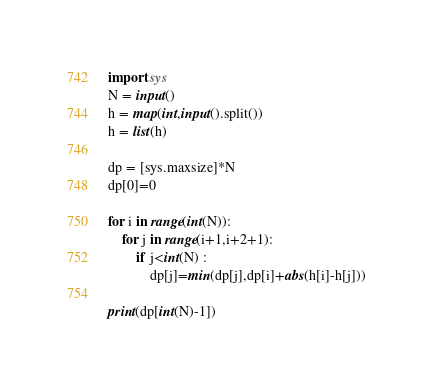<code> <loc_0><loc_0><loc_500><loc_500><_Python_>import sys
N = input()
h = map(int,input().split())
h = list(h)

dp = [sys.maxsize]*N
dp[0]=0

for i in range(int(N)):
    for j in range(i+1,i+2+1):
        if j<int(N) :
            dp[j]=min(dp[j],dp[i]+abs(h[i]-h[j]))

print(dp[int(N)-1])</code> 